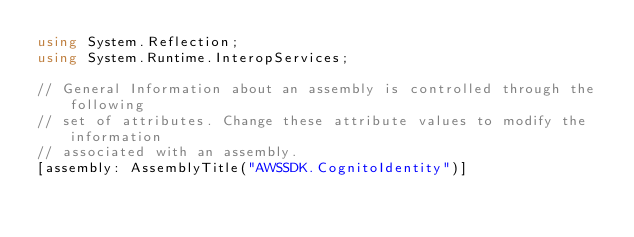Convert code to text. <code><loc_0><loc_0><loc_500><loc_500><_C#_>using System.Reflection;
using System.Runtime.InteropServices;

// General Information about an assembly is controlled through the following 
// set of attributes. Change these attribute values to modify the information
// associated with an assembly.
[assembly: AssemblyTitle("AWSSDK.CognitoIdentity")]</code> 